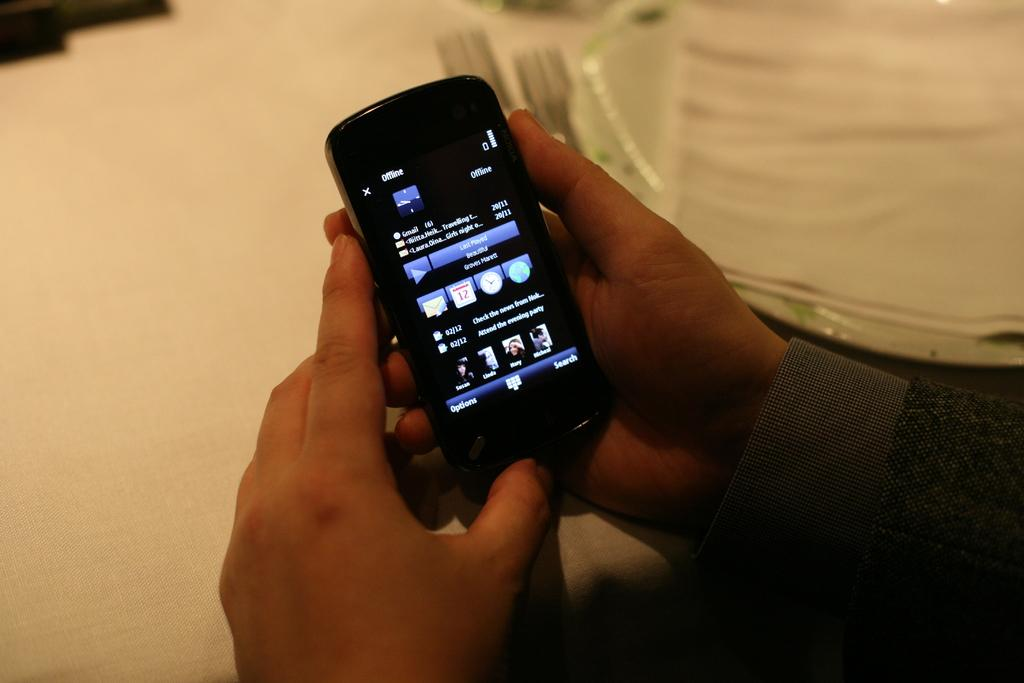Who or what is present in the image? There is a person in the image. What is the person doing with his hands? The person's hands are in the right corner of the image, and he is holding a mobile phone. What else can be seen on the table or surface in the image? There is a plate and two forks in the image, as well as other objects beside the person. Can you see any toads in the image? There are no toads present in the image. What type of zipper is being used by the person in the image? There is no zipper visible in the image, as the person is holding a mobile phone in his hands. 